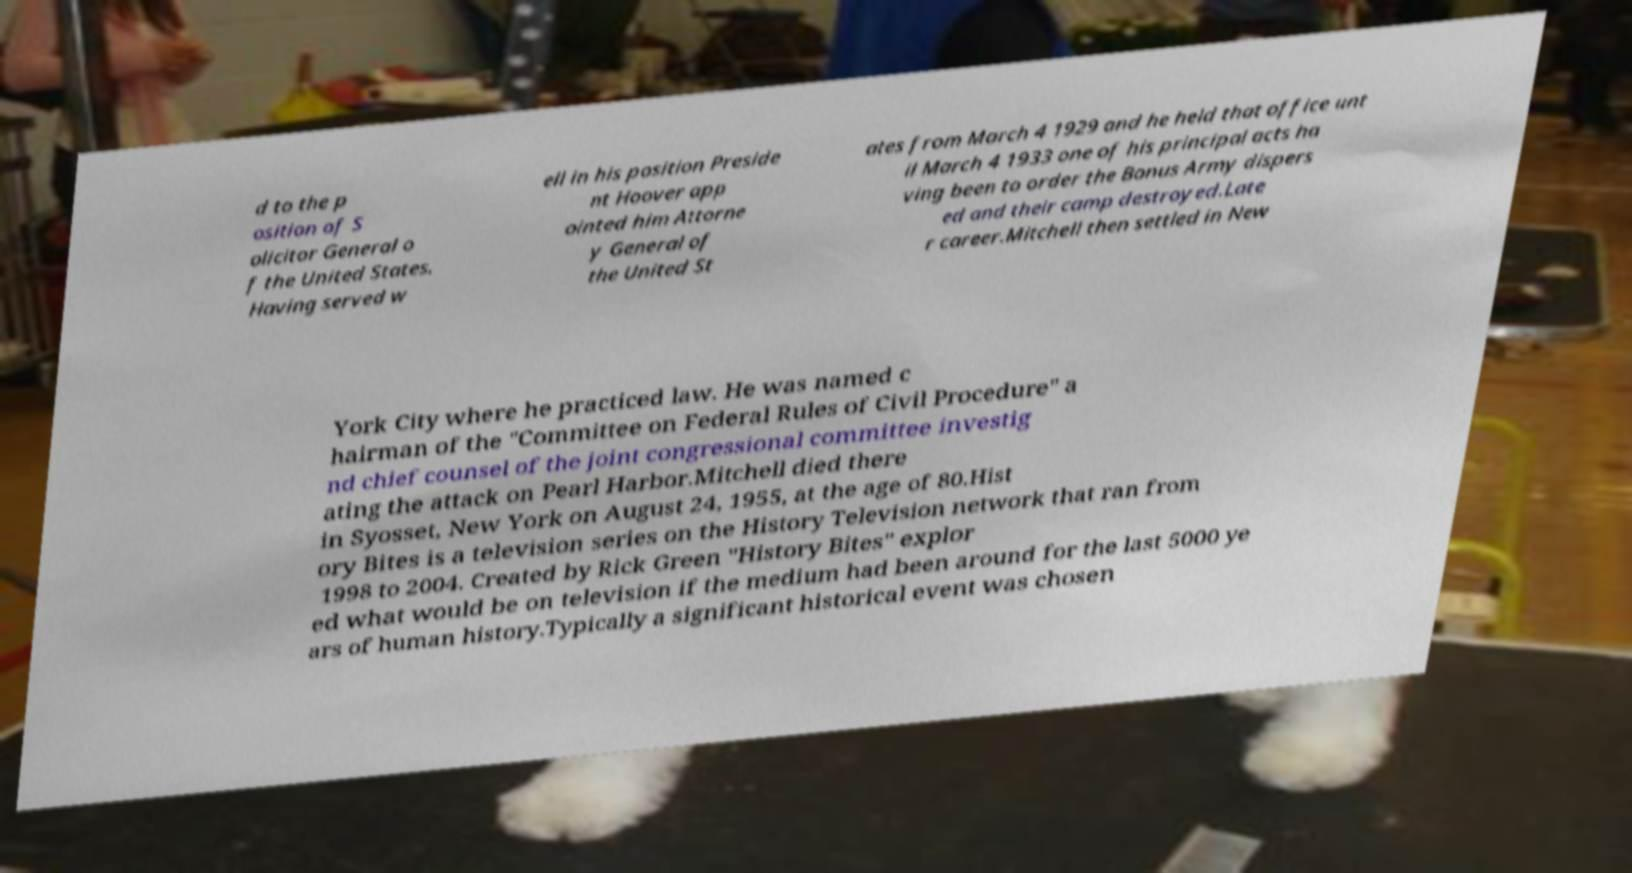I need the written content from this picture converted into text. Can you do that? d to the p osition of S olicitor General o f the United States. Having served w ell in his position Preside nt Hoover app ointed him Attorne y General of the United St ates from March 4 1929 and he held that office unt il March 4 1933 one of his principal acts ha ving been to order the Bonus Army dispers ed and their camp destroyed.Late r career.Mitchell then settled in New York City where he practiced law. He was named c hairman of the "Committee on Federal Rules of Civil Procedure" a nd chief counsel of the joint congressional committee investig ating the attack on Pearl Harbor.Mitchell died there in Syosset, New York on August 24, 1955, at the age of 80.Hist ory Bites is a television series on the History Television network that ran from 1998 to 2004. Created by Rick Green "History Bites" explor ed what would be on television if the medium had been around for the last 5000 ye ars of human history.Typically a significant historical event was chosen 